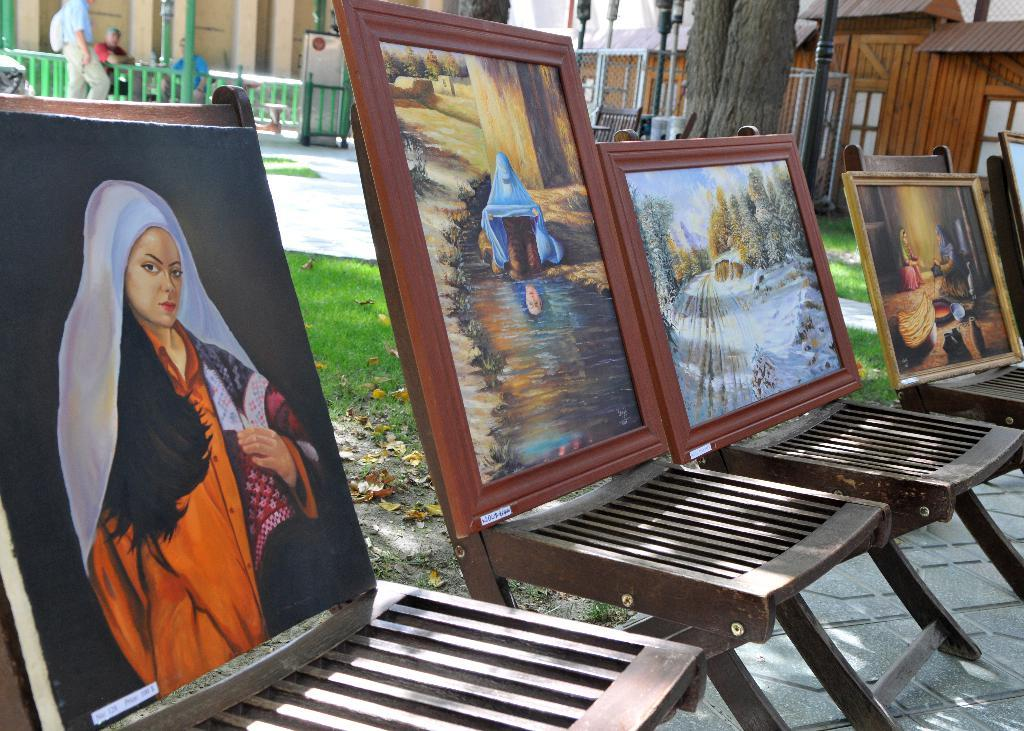What is the main subject of the image? The main subject of the image is a tree stem. What other structures can be seen in the image? There are houses and frames visible in the image. How much does the rat weigh in the image? There is no rat present in the image, so its weight cannot be determined. 